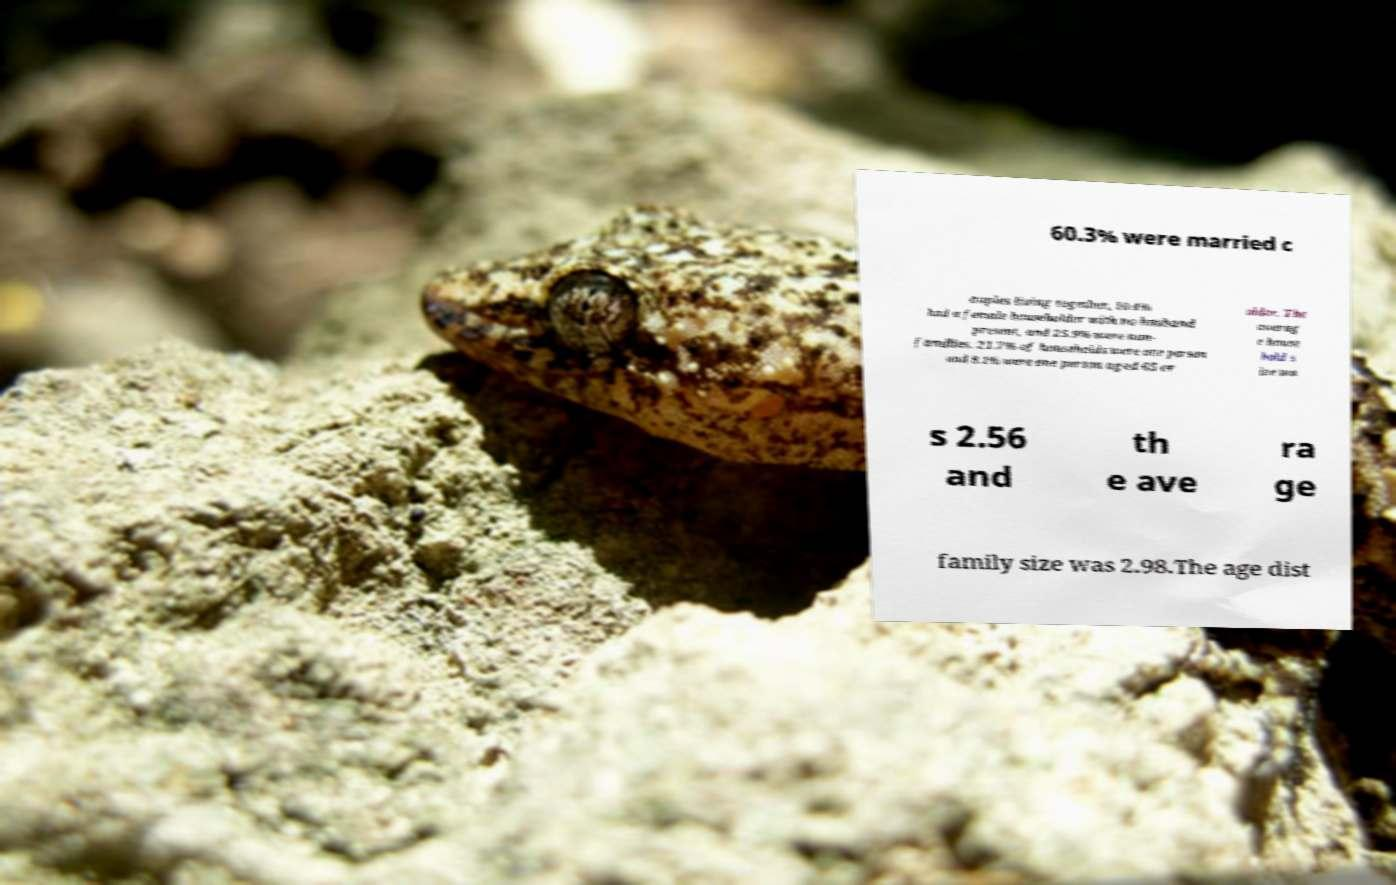Please identify and transcribe the text found in this image. 60.3% were married c ouples living together, 10.4% had a female householder with no husband present, and 25.9% were non- families. 21.7% of households were one person and 8.1% were one person aged 65 or older. The averag e house hold s ize wa s 2.56 and th e ave ra ge family size was 2.98.The age dist 